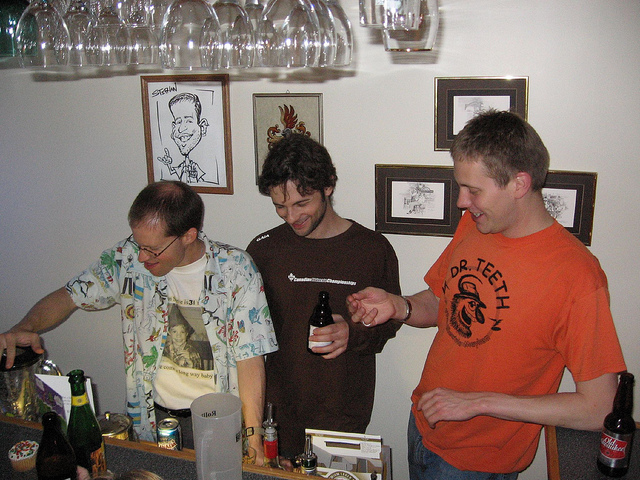Identify the text contained in this image. TEETH DR. Z STRAW 